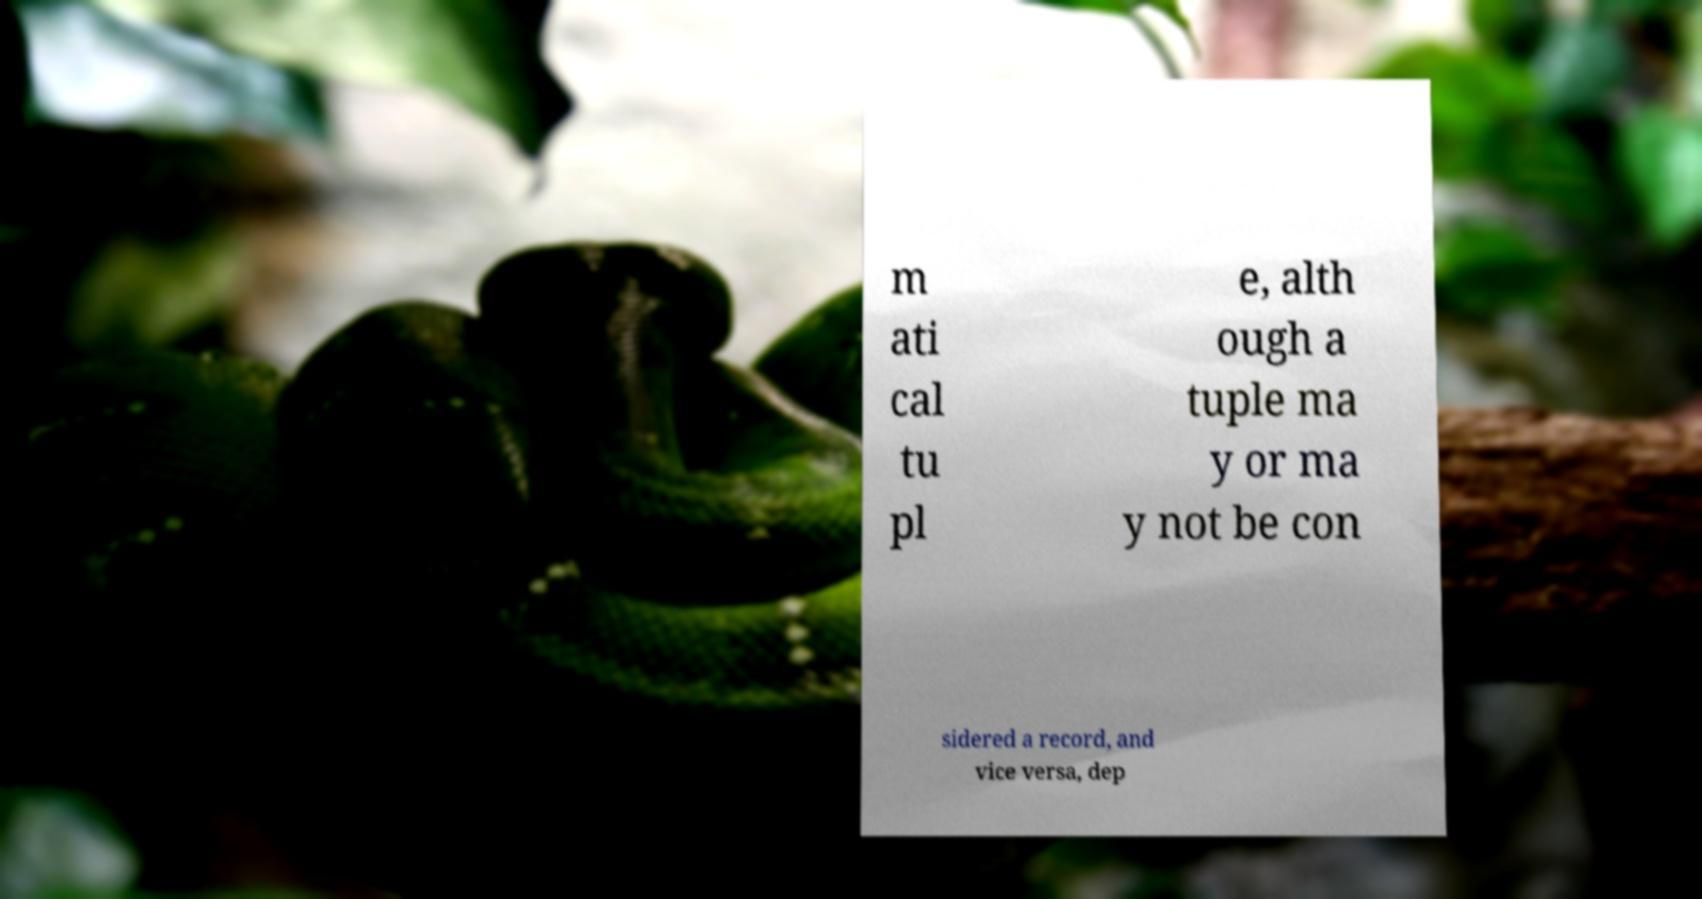I need the written content from this picture converted into text. Can you do that? m ati cal tu pl e, alth ough a tuple ma y or ma y not be con sidered a record, and vice versa, dep 